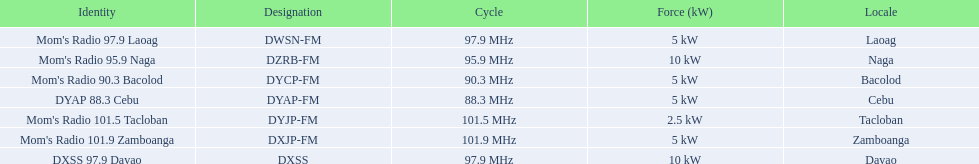What brandings have a power of 5 kw? Mom's Radio 97.9 Laoag, Mom's Radio 90.3 Bacolod, DYAP 88.3 Cebu, Mom's Radio 101.9 Zamboanga. Which of these has a call-sign beginning with dy? Mom's Radio 90.3 Bacolod, DYAP 88.3 Cebu. Which of those uses the lowest frequency? DYAP 88.3 Cebu. 